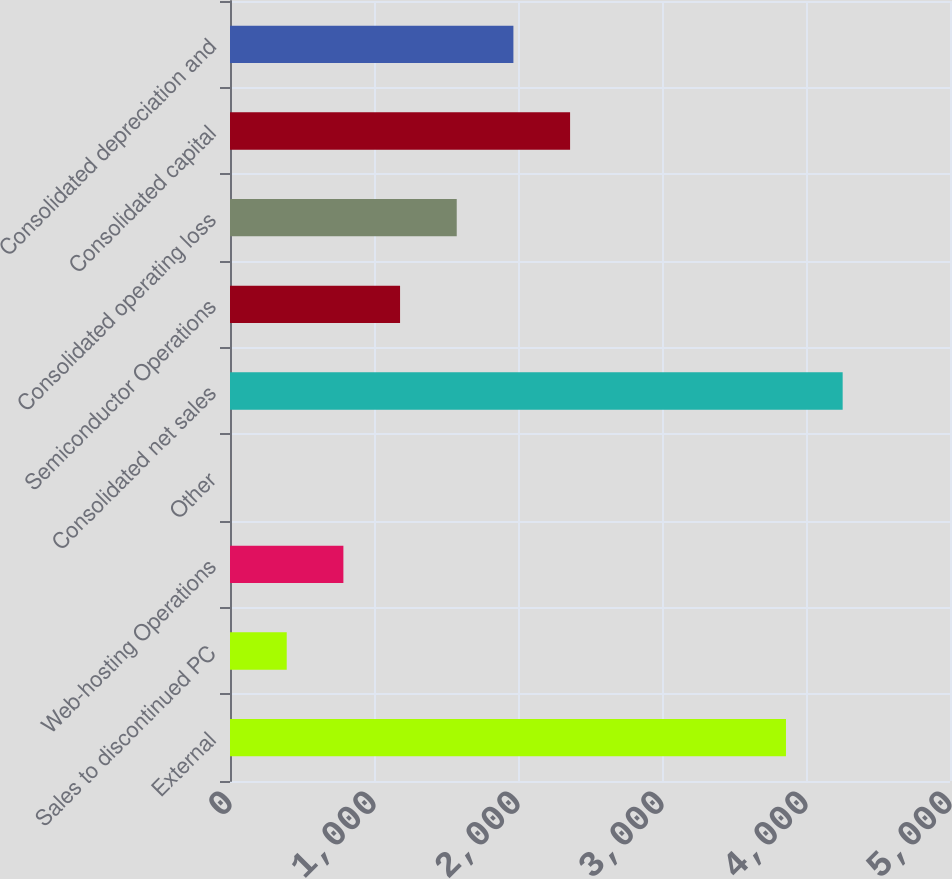Convert chart to OTSL. <chart><loc_0><loc_0><loc_500><loc_500><bar_chart><fcel>External<fcel>Sales to discontinued PC<fcel>Web-hosting Operations<fcel>Other<fcel>Consolidated net sales<fcel>Semiconductor Operations<fcel>Consolidated operating loss<fcel>Consolidated capital<fcel>Consolidated depreciation and<nl><fcel>3861<fcel>393.86<fcel>787.42<fcel>0.3<fcel>4254.56<fcel>1180.98<fcel>1574.54<fcel>2361.66<fcel>1968.1<nl></chart> 